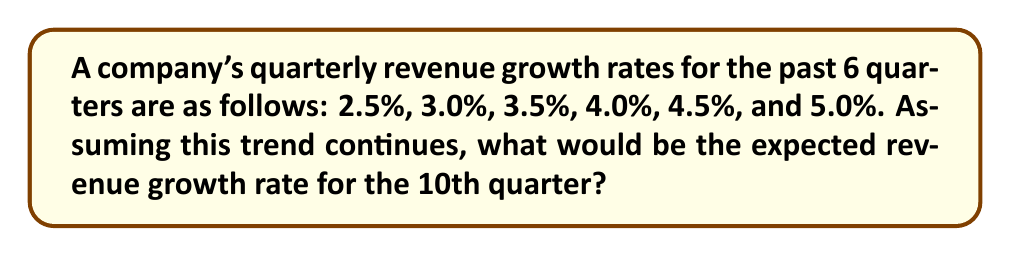Can you answer this question? To solve this problem, we need to analyze the pattern in the given growth rates and extrapolate to predict future performance. Let's approach this step-by-step:

1. Observe the pattern:
   Q1: 2.5%
   Q2: 3.0%
   Q3: 3.5%
   Q4: 4.0%
   Q5: 4.5%
   Q6: 5.0%

2. Calculate the difference between consecutive quarters:
   $3.0% - 2.5% = 0.5%$
   $3.5% - 3.0% = 0.5%$
   $4.0% - 3.5% = 0.5%$
   $4.5% - 4.0% = 0.5%$
   $5.0% - 4.5% = 0.5%$

3. We can see that the growth rate is increasing by 0.5% each quarter.

4. To find the 10th quarter's growth rate, we need to add 0.5% four more times to the 6th quarter's rate:

   $5.0% + (4 \times 0.5%) = 5.0% + 2.0% = 7.0%$

5. Alternatively, we can use the arithmetic sequence formula:
   $a_n = a_1 + (n-1)d$
   Where $a_n$ is the nth term, $a_1$ is the first term, $n$ is the position of the term, and $d$ is the common difference.

   $a_{10} = 2.5% + (10-1) \times 0.5% = 2.5% + 4.5% = 7.0%$

Therefore, the expected revenue growth rate for the 10th quarter would be 7.0%.
Answer: 7.0% 